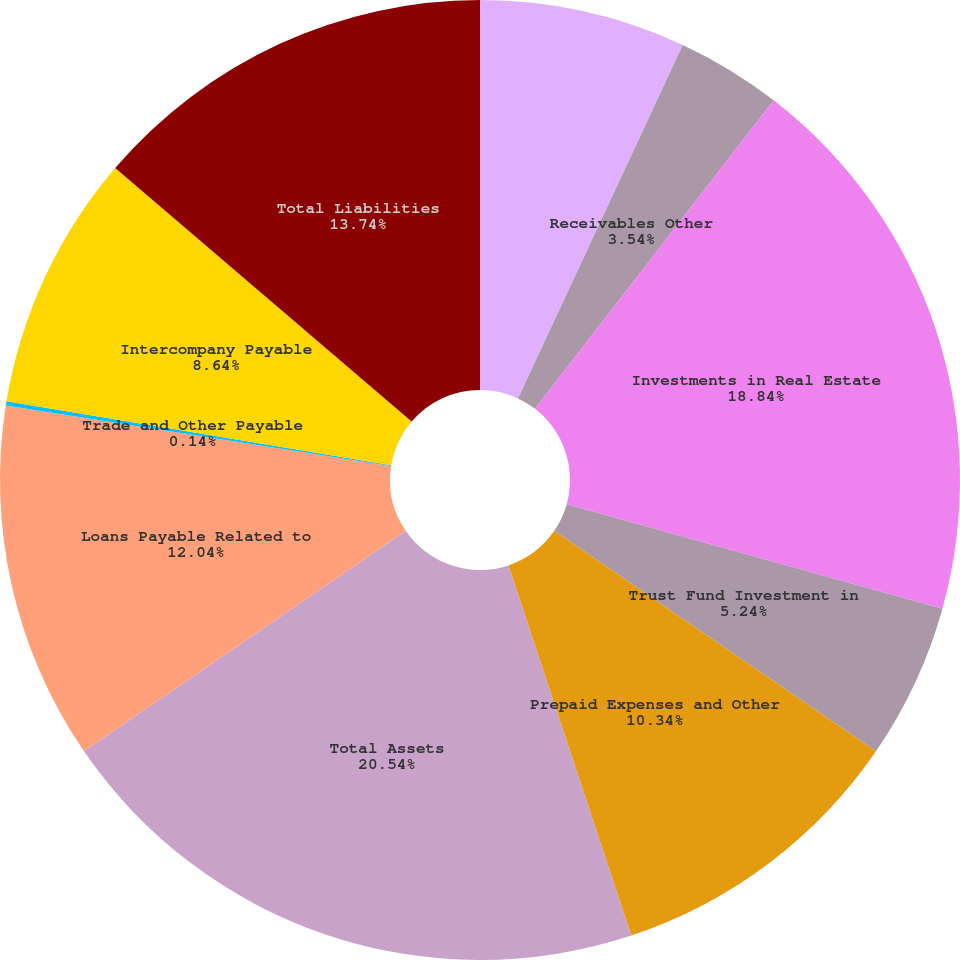Convert chart to OTSL. <chart><loc_0><loc_0><loc_500><loc_500><pie_chart><fcel>Cash and Cash Equivalents<fcel>Receivables Other<fcel>Investments in Real Estate<fcel>Trust Fund Investment in<fcel>Prepaid Expenses and Other<fcel>Total Assets<fcel>Loans Payable Related to<fcel>Trade and Other Payable<fcel>Intercompany Payable<fcel>Total Liabilities<nl><fcel>6.94%<fcel>3.54%<fcel>18.84%<fcel>5.24%<fcel>10.34%<fcel>20.54%<fcel>12.04%<fcel>0.14%<fcel>8.64%<fcel>13.74%<nl></chart> 